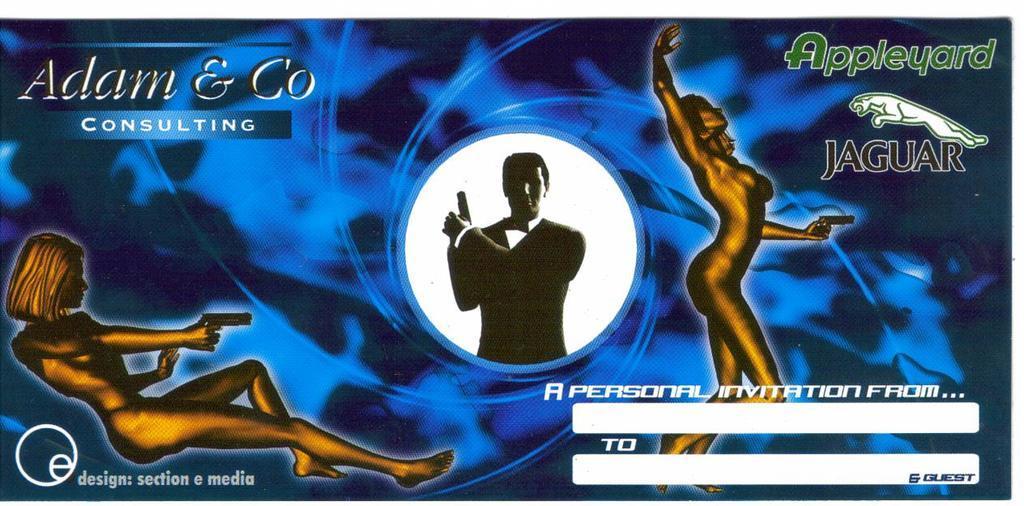Can you describe this image briefly? In this picture I can see the depiction of 3 persons holding guns and I see something is written on all the sides and I can see a logo of an animal on the right top of this picture. 